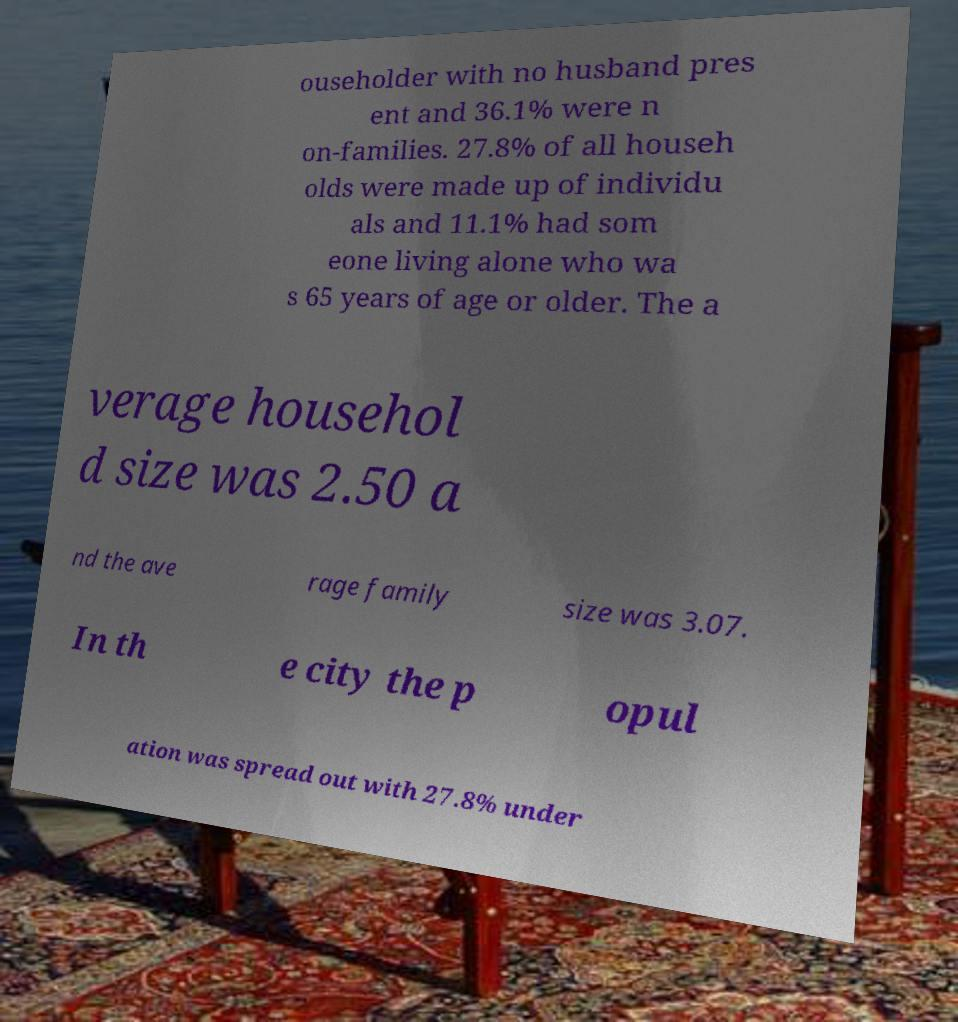Please read and relay the text visible in this image. What does it say? ouseholder with no husband pres ent and 36.1% were n on-families. 27.8% of all househ olds were made up of individu als and 11.1% had som eone living alone who wa s 65 years of age or older. The a verage househol d size was 2.50 a nd the ave rage family size was 3.07. In th e city the p opul ation was spread out with 27.8% under 